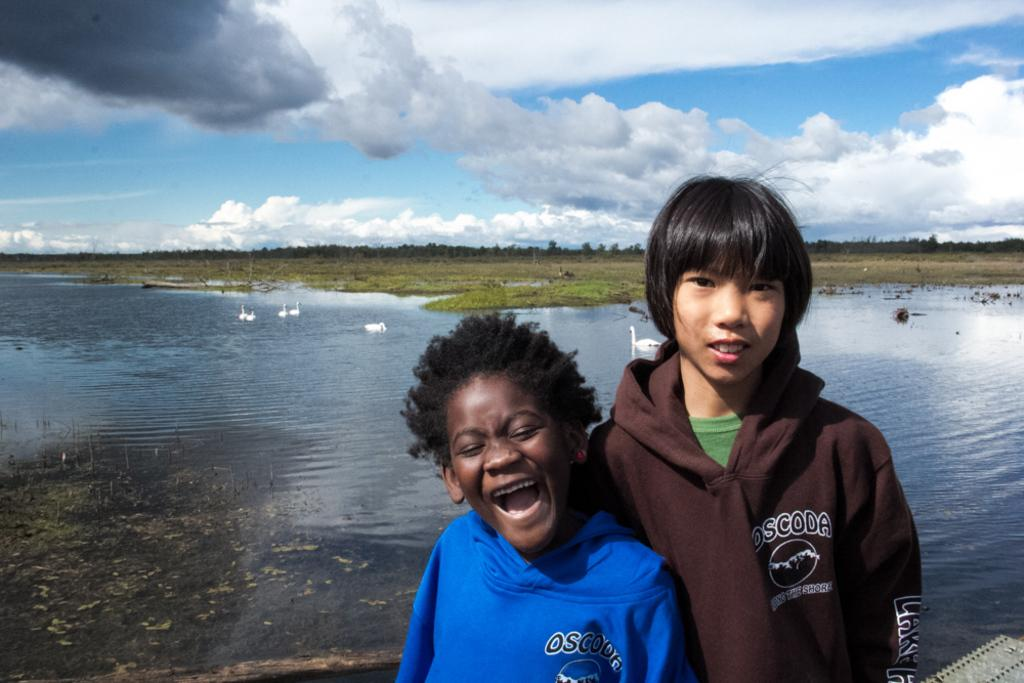How many children are in the image? There are two children in the image. What are the children wearing? The children are wearing clothes. What can be seen in the water in the image? There are birds in the water. What type of vegetation is present in the image? There is grass and trees in the image. What is the condition of the sky in the image? The sky is cloudy in the image. Can you tell me how many bears are playing with a whip in the image? There are no bears or whips present in the image. Who is the friend of the children in the image? The provided facts do not mention any friends of the children in the image. 